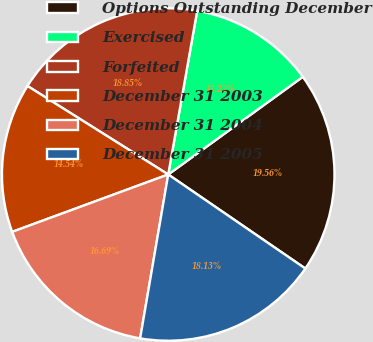Convert chart to OTSL. <chart><loc_0><loc_0><loc_500><loc_500><pie_chart><fcel>Options Outstanding December<fcel>Exercised<fcel>Forfeited<fcel>December 31 2003<fcel>December 31 2004<fcel>December 31 2005<nl><fcel>19.56%<fcel>12.22%<fcel>18.85%<fcel>14.54%<fcel>16.69%<fcel>18.13%<nl></chart> 